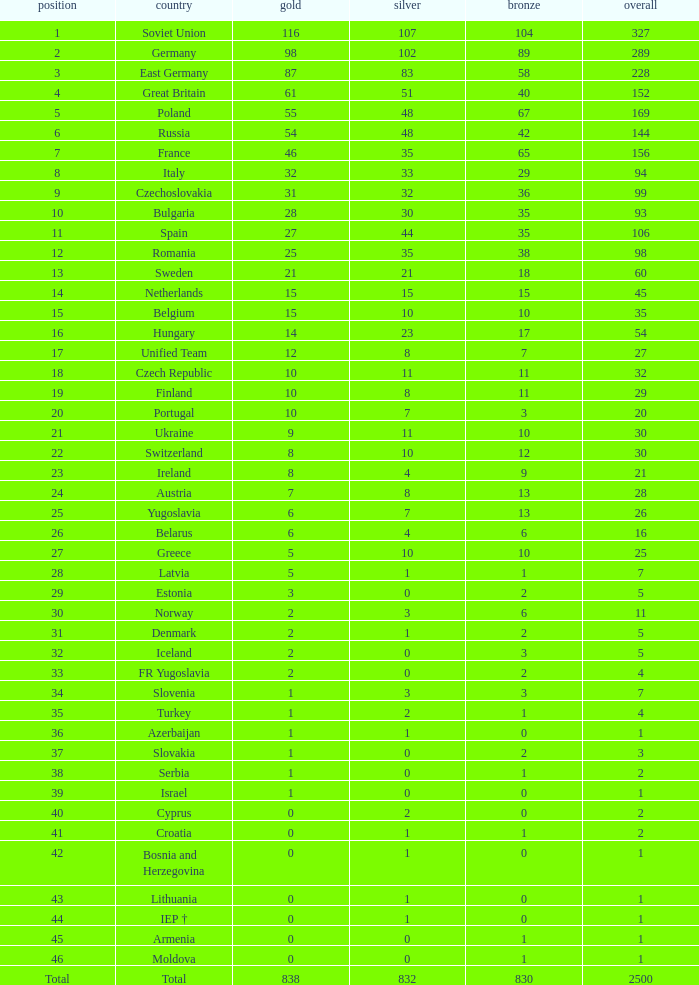What is the rank of the nation with more than 0 silver medals and 38 bronze medals? 12.0. Can you give me this table as a dict? {'header': ['position', 'country', 'gold', 'silver', 'bronze', 'overall'], 'rows': [['1', 'Soviet Union', '116', '107', '104', '327'], ['2', 'Germany', '98', '102', '89', '289'], ['3', 'East Germany', '87', '83', '58', '228'], ['4', 'Great Britain', '61', '51', '40', '152'], ['5', 'Poland', '55', '48', '67', '169'], ['6', 'Russia', '54', '48', '42', '144'], ['7', 'France', '46', '35', '65', '156'], ['8', 'Italy', '32', '33', '29', '94'], ['9', 'Czechoslovakia', '31', '32', '36', '99'], ['10', 'Bulgaria', '28', '30', '35', '93'], ['11', 'Spain', '27', '44', '35', '106'], ['12', 'Romania', '25', '35', '38', '98'], ['13', 'Sweden', '21', '21', '18', '60'], ['14', 'Netherlands', '15', '15', '15', '45'], ['15', 'Belgium', '15', '10', '10', '35'], ['16', 'Hungary', '14', '23', '17', '54'], ['17', 'Unified Team', '12', '8', '7', '27'], ['18', 'Czech Republic', '10', '11', '11', '32'], ['19', 'Finland', '10', '8', '11', '29'], ['20', 'Portugal', '10', '7', '3', '20'], ['21', 'Ukraine', '9', '11', '10', '30'], ['22', 'Switzerland', '8', '10', '12', '30'], ['23', 'Ireland', '8', '4', '9', '21'], ['24', 'Austria', '7', '8', '13', '28'], ['25', 'Yugoslavia', '6', '7', '13', '26'], ['26', 'Belarus', '6', '4', '6', '16'], ['27', 'Greece', '5', '10', '10', '25'], ['28', 'Latvia', '5', '1', '1', '7'], ['29', 'Estonia', '3', '0', '2', '5'], ['30', 'Norway', '2', '3', '6', '11'], ['31', 'Denmark', '2', '1', '2', '5'], ['32', 'Iceland', '2', '0', '3', '5'], ['33', 'FR Yugoslavia', '2', '0', '2', '4'], ['34', 'Slovenia', '1', '3', '3', '7'], ['35', 'Turkey', '1', '2', '1', '4'], ['36', 'Azerbaijan', '1', '1', '0', '1'], ['37', 'Slovakia', '1', '0', '2', '3'], ['38', 'Serbia', '1', '0', '1', '2'], ['39', 'Israel', '1', '0', '0', '1'], ['40', 'Cyprus', '0', '2', '0', '2'], ['41', 'Croatia', '0', '1', '1', '2'], ['42', 'Bosnia and Herzegovina', '0', '1', '0', '1'], ['43', 'Lithuania', '0', '1', '0', '1'], ['44', 'IEP †', '0', '1', '0', '1'], ['45', 'Armenia', '0', '0', '1', '1'], ['46', 'Moldova', '0', '0', '1', '1'], ['Total', 'Total', '838', '832', '830', '2500']]} 